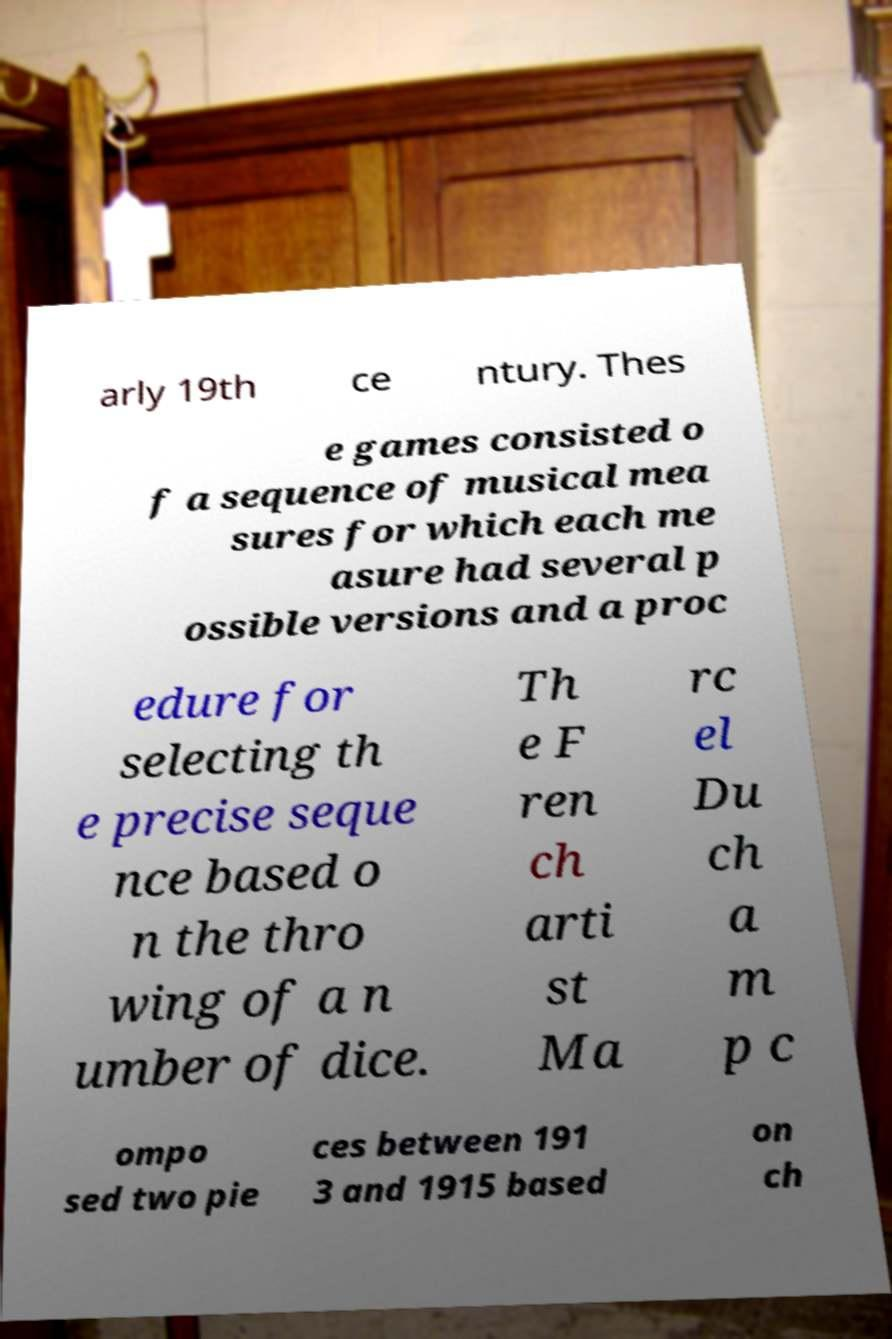What messages or text are displayed in this image? I need them in a readable, typed format. arly 19th ce ntury. Thes e games consisted o f a sequence of musical mea sures for which each me asure had several p ossible versions and a proc edure for selecting th e precise seque nce based o n the thro wing of a n umber of dice. Th e F ren ch arti st Ma rc el Du ch a m p c ompo sed two pie ces between 191 3 and 1915 based on ch 